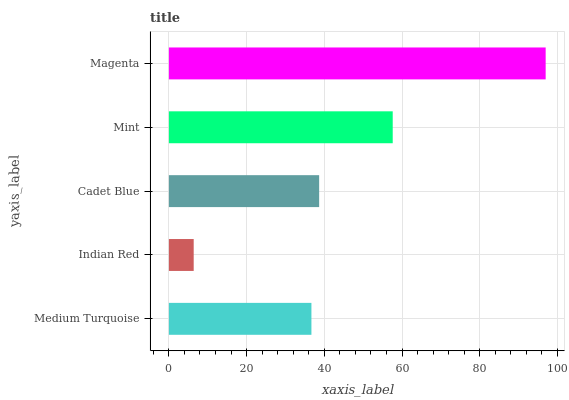Is Indian Red the minimum?
Answer yes or no. Yes. Is Magenta the maximum?
Answer yes or no. Yes. Is Cadet Blue the minimum?
Answer yes or no. No. Is Cadet Blue the maximum?
Answer yes or no. No. Is Cadet Blue greater than Indian Red?
Answer yes or no. Yes. Is Indian Red less than Cadet Blue?
Answer yes or no. Yes. Is Indian Red greater than Cadet Blue?
Answer yes or no. No. Is Cadet Blue less than Indian Red?
Answer yes or no. No. Is Cadet Blue the high median?
Answer yes or no. Yes. Is Cadet Blue the low median?
Answer yes or no. Yes. Is Indian Red the high median?
Answer yes or no. No. Is Mint the low median?
Answer yes or no. No. 